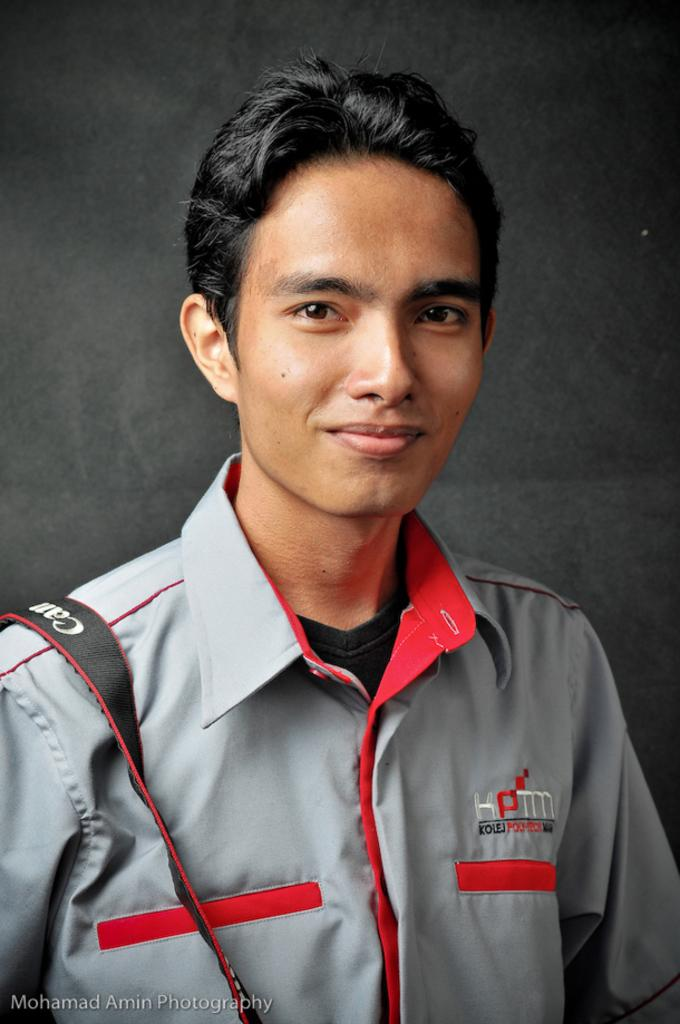<image>
Write a terse but informative summary of the picture. A man wearing a KPTM jacket poses for a picture. 